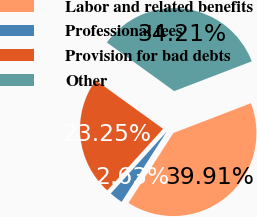Convert chart. <chart><loc_0><loc_0><loc_500><loc_500><pie_chart><fcel>Labor and related benefits<fcel>Professional fees<fcel>Provision for bad debts<fcel>Other<nl><fcel>39.91%<fcel>2.63%<fcel>23.25%<fcel>34.21%<nl></chart> 